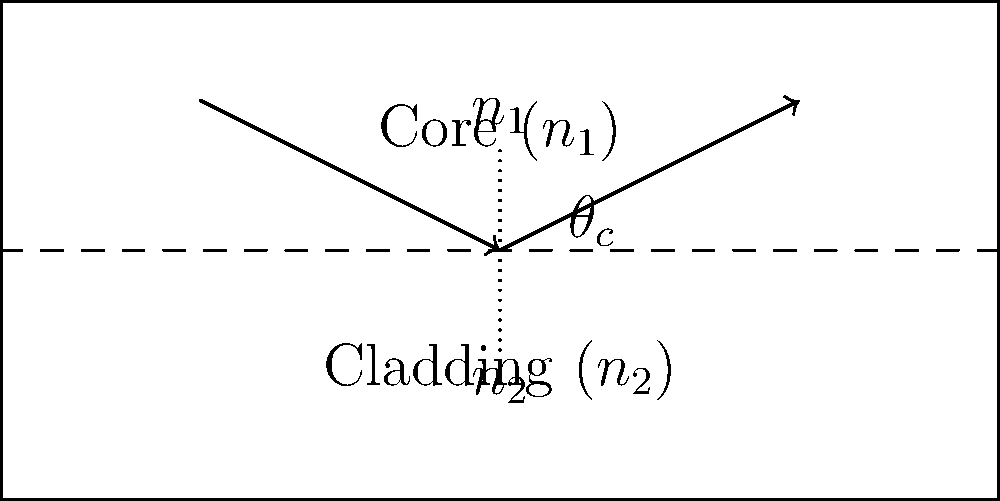In an optical fiber, the core has a refractive index ($n_1$) of 1.50, and the cladding has a refractive index ($n_2$) of 1.48. Calculate the critical angle ($\theta_c$) for total internal reflection at the core-cladding interface. To calculate the critical angle for total internal reflection in an optical fiber, we can use Snell's law and the principle of total internal reflection. Here's the step-by-step process:

1. Recall Snell's law: $n_1 \sin(\theta_1) = n_2 \sin(\theta_2)$

2. At the critical angle, $\theta_2 = 90°$ (the refracted ray is parallel to the interface)

3. Substituting these into Snell's law:
   $n_1 \sin(\theta_c) = n_2 \sin(90°)$

4. Since $\sin(90°) = 1$, we get:
   $n_1 \sin(\theta_c) = n_2$

5. Solving for $\theta_c$:
   $\sin(\theta_c) = \frac{n_2}{n_1}$

6. Taking the inverse sine (arcsin) of both sides:
   $\theta_c = \arcsin(\frac{n_2}{n_1})$

7. Now, substitute the given values:
   $\theta_c = \arcsin(\frac{1.48}{1.50})$

8. Calculate the result:
   $\theta_c \approx 80.60°$

Therefore, the critical angle for total internal reflection in this optical fiber is approximately 80.60°.
Answer: $\theta_c \approx 80.60°$ 